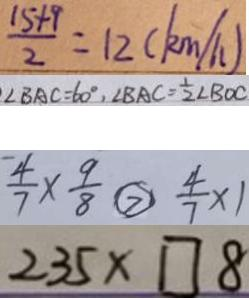<formula> <loc_0><loc_0><loc_500><loc_500>\frac { 1 5 + 9 } { 2 } = 1 2 ( k m / h ) 
 \angle B A C = 6 0 ^ { \circ } , \angle B A C = \frac { 1 } { 2 } \angle B O C 
 \frac { 4 } { 7 } \times \frac { 9 } { 8 } \textcircled { > } \frac { 4 } { 7 } \times 1 
 2 3 5 \times \square 8</formula> 